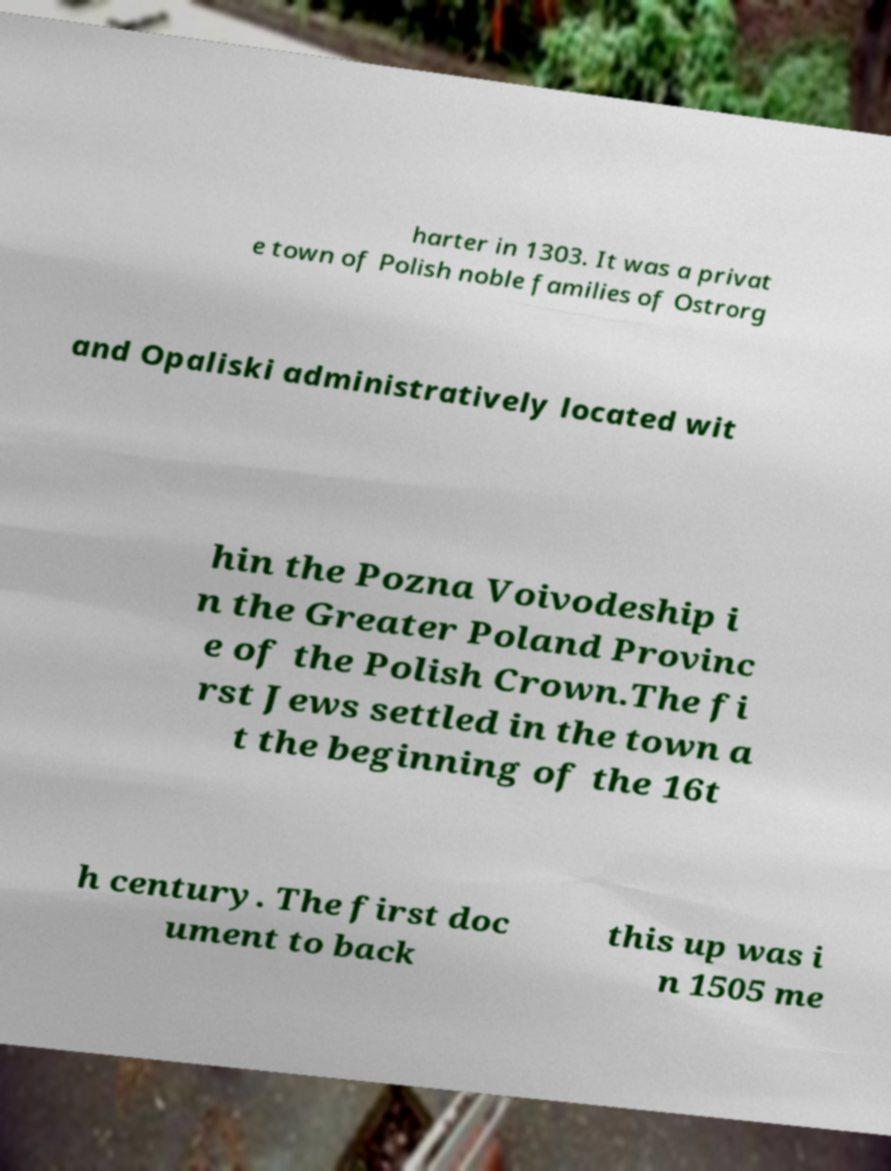There's text embedded in this image that I need extracted. Can you transcribe it verbatim? harter in 1303. It was a privat e town of Polish noble families of Ostrorg and Opaliski administratively located wit hin the Pozna Voivodeship i n the Greater Poland Provinc e of the Polish Crown.The fi rst Jews settled in the town a t the beginning of the 16t h century. The first doc ument to back this up was i n 1505 me 